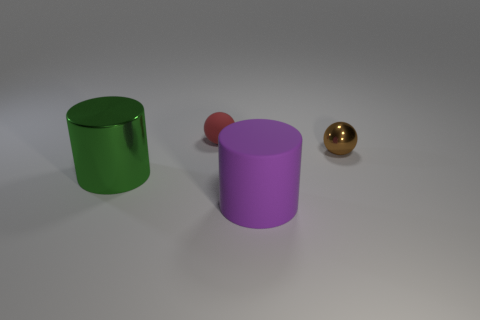What number of big green shiny cubes are there?
Your answer should be very brief. 0. Do the large purple object and the big thing that is to the left of the red rubber sphere have the same shape?
Provide a short and direct response. Yes. Is the number of purple cylinders that are behind the tiny rubber thing less than the number of rubber balls that are in front of the green metal thing?
Ensure brevity in your answer.  No. Are there any other things that are the same shape as the green metallic thing?
Your answer should be compact. Yes. Is the green thing the same shape as the purple matte object?
Your response must be concise. Yes. Are there any other things that have the same material as the red ball?
Ensure brevity in your answer.  Yes. The metal ball is what size?
Provide a short and direct response. Small. There is a object that is both in front of the brown shiny thing and on the right side of the big green shiny object; what color is it?
Ensure brevity in your answer.  Purple. Are there more cyan rubber cubes than metal objects?
Keep it short and to the point. No. What number of things are either balls or spheres left of the small brown metal object?
Offer a terse response. 2. 